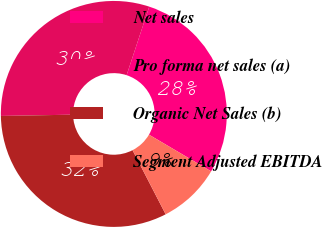<chart> <loc_0><loc_0><loc_500><loc_500><pie_chart><fcel>Net sales<fcel>Pro forma net sales (a)<fcel>Organic Net Sales (b)<fcel>Segment Adjusted EBITDA<nl><fcel>28.41%<fcel>30.36%<fcel>32.3%<fcel>8.93%<nl></chart> 